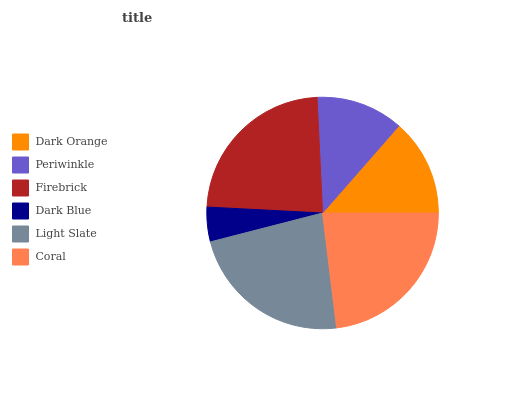Is Dark Blue the minimum?
Answer yes or no. Yes. Is Firebrick the maximum?
Answer yes or no. Yes. Is Periwinkle the minimum?
Answer yes or no. No. Is Periwinkle the maximum?
Answer yes or no. No. Is Dark Orange greater than Periwinkle?
Answer yes or no. Yes. Is Periwinkle less than Dark Orange?
Answer yes or no. Yes. Is Periwinkle greater than Dark Orange?
Answer yes or no. No. Is Dark Orange less than Periwinkle?
Answer yes or no. No. Is Light Slate the high median?
Answer yes or no. Yes. Is Dark Orange the low median?
Answer yes or no. Yes. Is Periwinkle the high median?
Answer yes or no. No. Is Coral the low median?
Answer yes or no. No. 